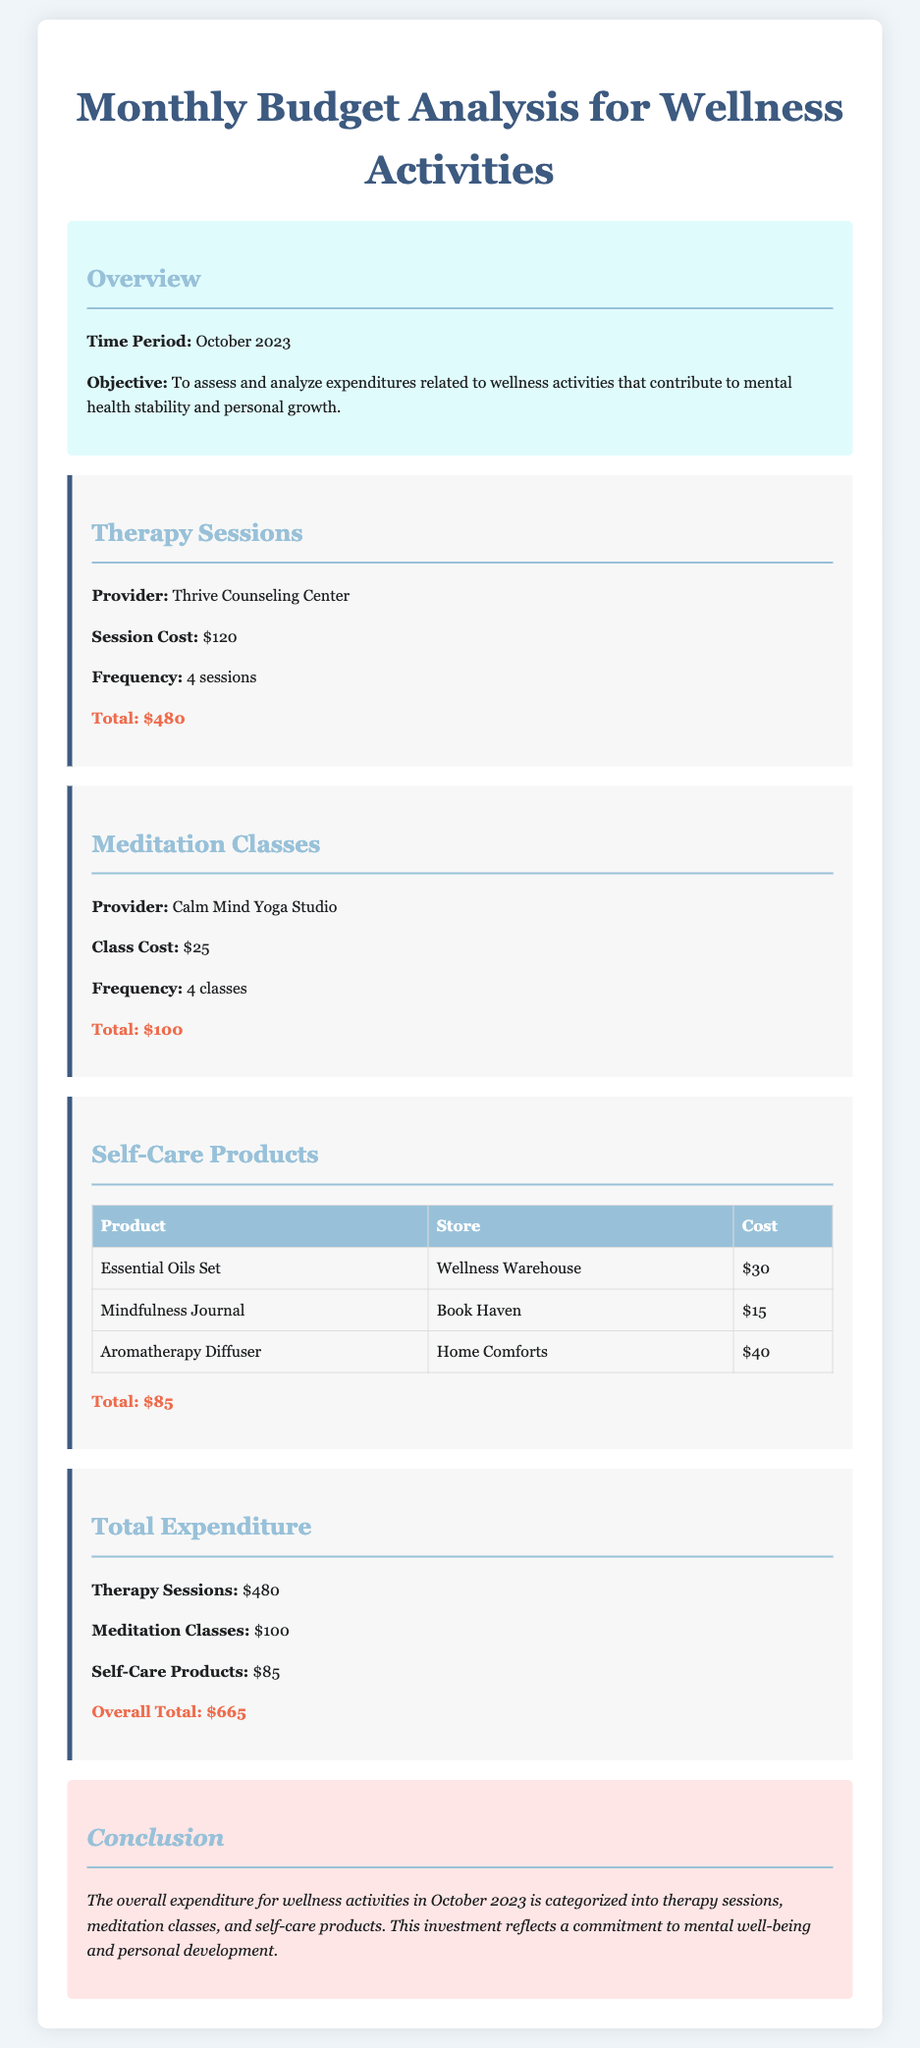What is the time period covered in this report? The time period is stated clearly in the overview section of the document.
Answer: October 2023 What is the cost per therapy session? The document specifies the cost of each therapy session in the Therapy Sessions category.
Answer: $120 How many meditation classes were attended? The frequency of meditation classes attended is mentioned in the Meditation Classes category.
Answer: 4 classes What is the total expenditure on self-care products? The document provides a summary of costs for self-care products in the respective category.
Answer: $85 Which provider offers meditation classes? The name of the provider for meditation classes is found in the Meditation Classes section.
Answer: Calm Mind Yoga Studio What is the overall total expenditure on wellness activities? The overall total expenditure is summarized in the Total Expenditure category, aggregating all wellness activities.
Answer: $665 How much was spent on essential oils? The cost of the essential oils set is provided in the Self-Care Products table.
Answer: $30 What is the conclusion of the report? The conclusion summarizes the overall message of the report regarding the importance of the expenditures.
Answer: This investment reflects a commitment to mental well-being and personal development What product costs the most among self-care products? The self-care products section lists individual costs that can be compared to determine the highest cost.
Answer: Aromatherapy Diffuser Which category had the lowest expenditure? The expenditure amounts for each category can be compared to identify the one with the lowest total.
Answer: Meditation Classes 